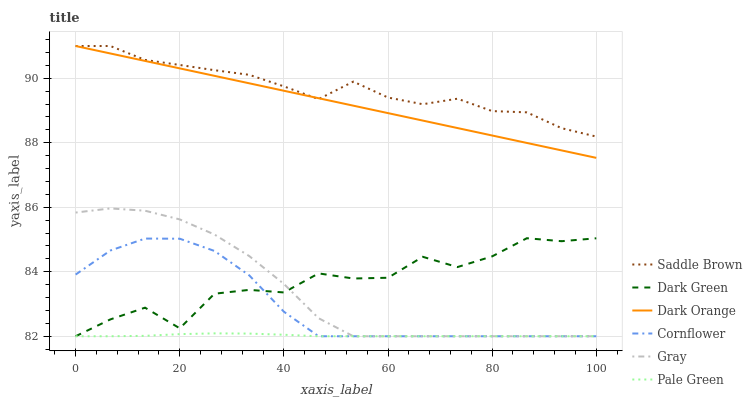Does Pale Green have the minimum area under the curve?
Answer yes or no. Yes. Does Saddle Brown have the maximum area under the curve?
Answer yes or no. Yes. Does Gray have the minimum area under the curve?
Answer yes or no. No. Does Gray have the maximum area under the curve?
Answer yes or no. No. Is Dark Orange the smoothest?
Answer yes or no. Yes. Is Dark Green the roughest?
Answer yes or no. Yes. Is Gray the smoothest?
Answer yes or no. No. Is Gray the roughest?
Answer yes or no. No. Does Gray have the lowest value?
Answer yes or no. Yes. Does Saddle Brown have the lowest value?
Answer yes or no. No. Does Saddle Brown have the highest value?
Answer yes or no. Yes. Does Gray have the highest value?
Answer yes or no. No. Is Pale Green less than Saddle Brown?
Answer yes or no. Yes. Is Dark Orange greater than Pale Green?
Answer yes or no. Yes. Does Pale Green intersect Cornflower?
Answer yes or no. Yes. Is Pale Green less than Cornflower?
Answer yes or no. No. Is Pale Green greater than Cornflower?
Answer yes or no. No. Does Pale Green intersect Saddle Brown?
Answer yes or no. No. 